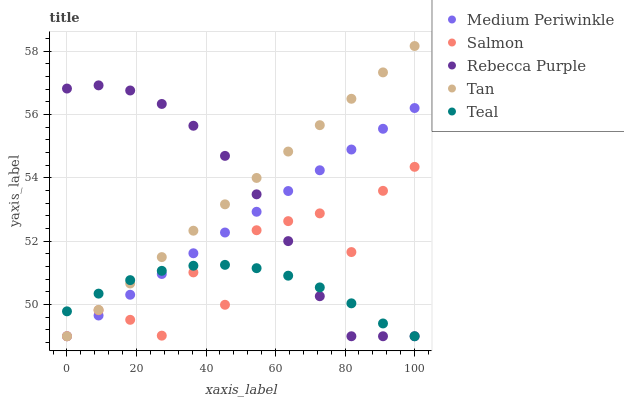Does Teal have the minimum area under the curve?
Answer yes or no. Yes. Does Tan have the maximum area under the curve?
Answer yes or no. Yes. Does Medium Periwinkle have the minimum area under the curve?
Answer yes or no. No. Does Medium Periwinkle have the maximum area under the curve?
Answer yes or no. No. Is Tan the smoothest?
Answer yes or no. Yes. Is Salmon the roughest?
Answer yes or no. Yes. Is Medium Periwinkle the smoothest?
Answer yes or no. No. Is Medium Periwinkle the roughest?
Answer yes or no. No. Does Salmon have the lowest value?
Answer yes or no. Yes. Does Tan have the highest value?
Answer yes or no. Yes. Does Medium Periwinkle have the highest value?
Answer yes or no. No. Does Salmon intersect Tan?
Answer yes or no. Yes. Is Salmon less than Tan?
Answer yes or no. No. Is Salmon greater than Tan?
Answer yes or no. No. 